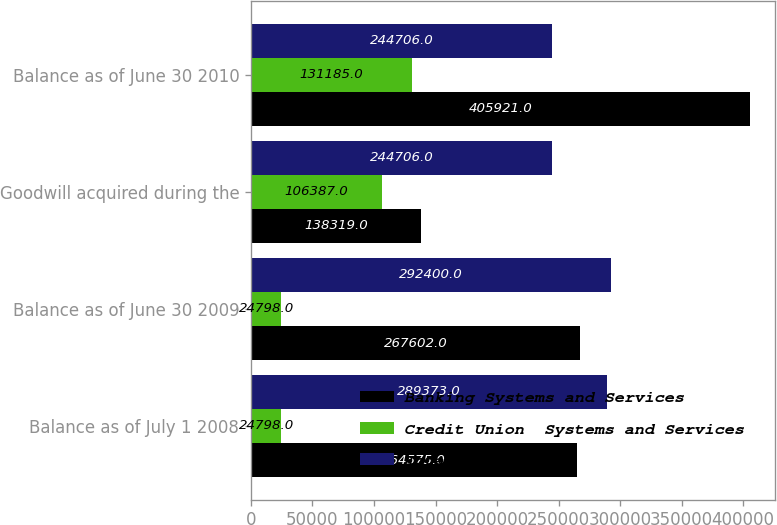Convert chart. <chart><loc_0><loc_0><loc_500><loc_500><stacked_bar_chart><ecel><fcel>Balance as of July 1 2008<fcel>Balance as of June 30 2009<fcel>Goodwill acquired during the<fcel>Balance as of June 30 2010<nl><fcel>Banking Systems and Services<fcel>264575<fcel>267602<fcel>138319<fcel>405921<nl><fcel>Credit Union  Systems and Services<fcel>24798<fcel>24798<fcel>106387<fcel>131185<nl><fcel>Total<fcel>289373<fcel>292400<fcel>244706<fcel>244706<nl></chart> 